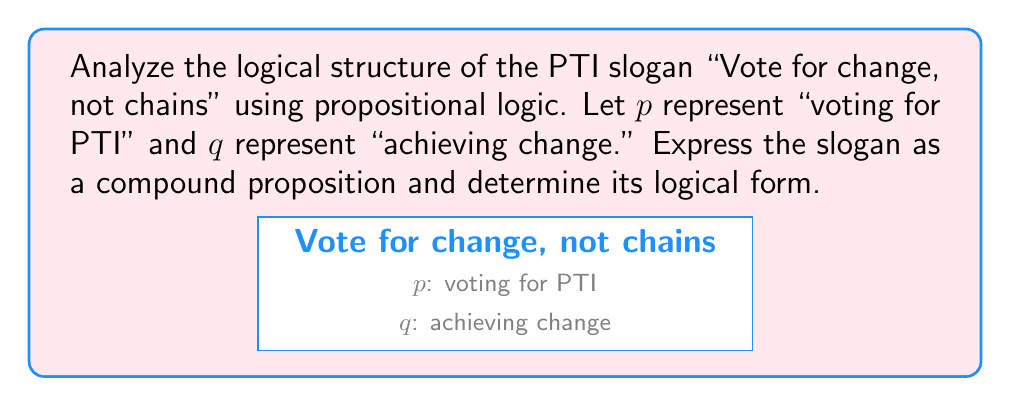Show me your answer to this math problem. Let's break this down step-by-step:

1) First, we need to identify the main components of the slogan:
   - "Vote for change" implies that voting for PTI leads to change
   - "not chains" implies that not voting for PTI leads to no change (or status quo)

2) We can express these ideas using propositional logic:
   - $p \rightarrow q$ (voting for PTI implies achieving change)
   - $\neg p \rightarrow \neg q$ (not voting for PTI implies not achieving change)

3) The slogan combines these two ideas, suggesting that both are true. In propositional logic, we can express this using the conjunction operator ($\land$):

   $$(p \rightarrow q) \land (\neg p \rightarrow \neg q)$$

4) This logical form is known as a biconditional or material equivalence. It's equivalent to:

   $$p \leftrightarrow q$$

5) This means that voting for PTI is necessary and sufficient for achieving change, according to the slogan's logic.

6) In terms of truth tables, this proposition is true when both $p$ and $q$ have the same truth value (both true or both false), and false otherwise.
Answer: $p \leftrightarrow q$ 